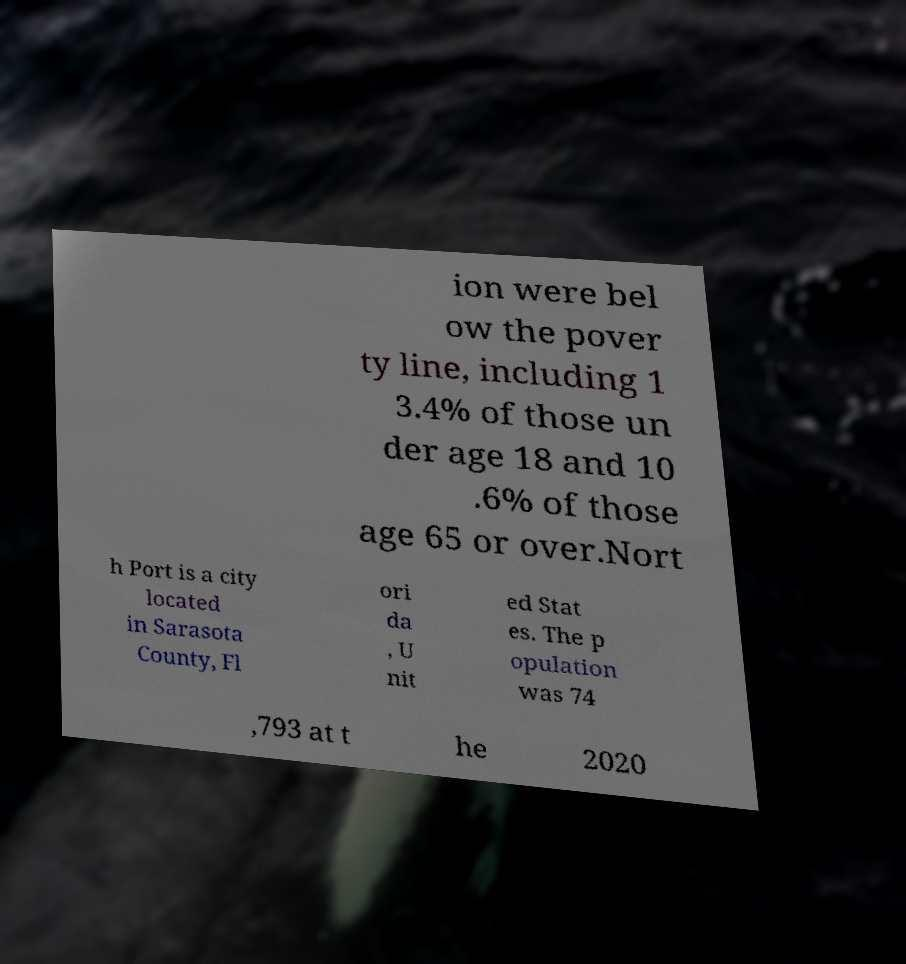Please identify and transcribe the text found in this image. ion were bel ow the pover ty line, including 1 3.4% of those un der age 18 and 10 .6% of those age 65 or over.Nort h Port is a city located in Sarasota County, Fl ori da , U nit ed Stat es. The p opulation was 74 ,793 at t he 2020 